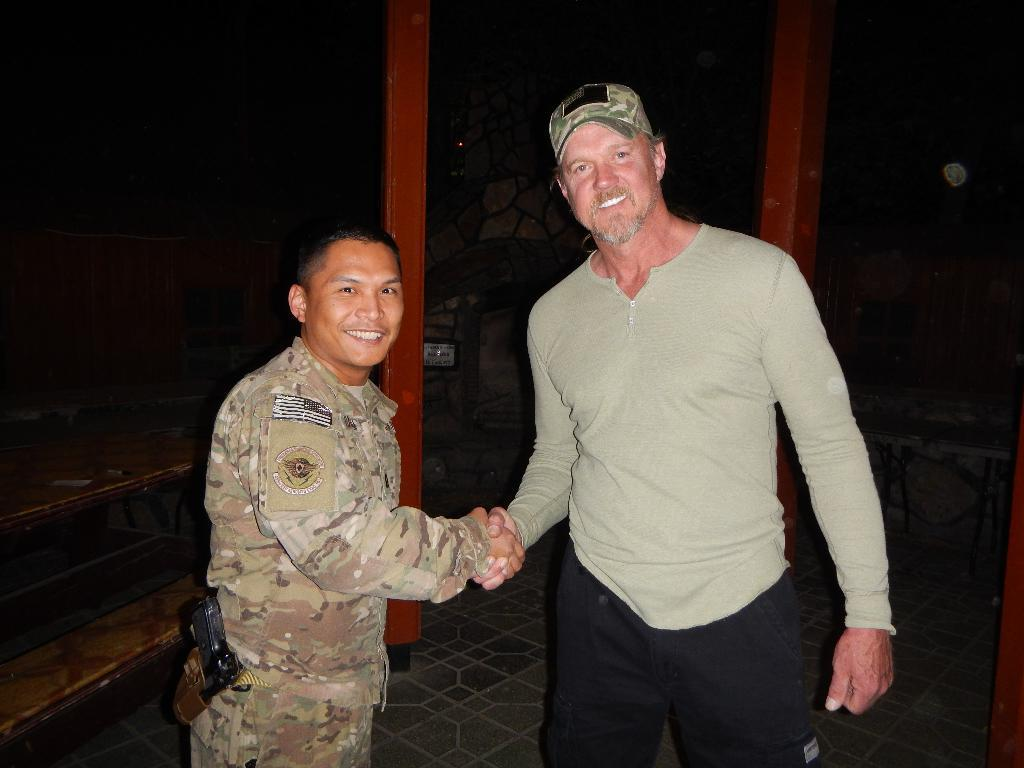How many people are in the image? There are two persons in the image. What are the persons doing in the image? The persons are standing and smiling. What objects can be seen in the image besides the people? There are poles and a table in the image. What is the color of the background in the image? The background of the image is dark. How much money is the person holding in the image? There is no money visible in the image; the persons are simply standing and smiling. What type of finger is the person pointing with in the image? There is no finger pointing in the image; the persons are standing and smiling with their hands at their sides. 